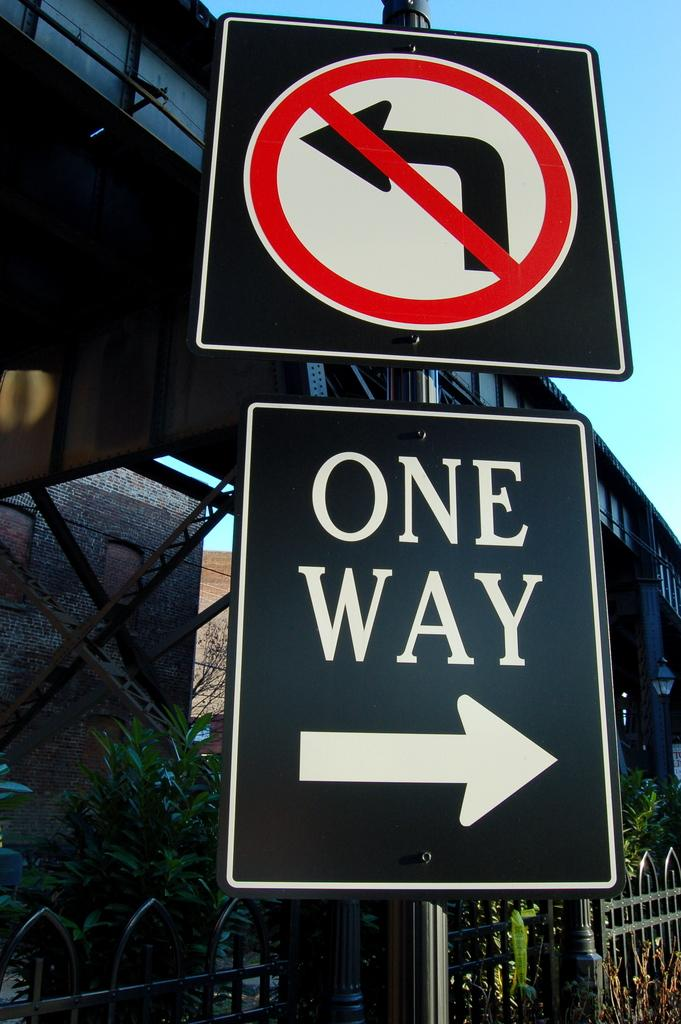What is attached to the pole in the image? There are boards on a pole in the image. What can be read on the boards? There is text on the boards. What can be seen in the background of the image? There is a building and plants in the background of the image. What architectural feature is present in the image? There is a railing in the image. What is visible at the top of the image? The sky is visible at the top of the image. Can you tell me how many people are swimming in the image? There is no indication of swimming or any people in the image. What type of recess is shown in the image? There is no recess present in the image. 